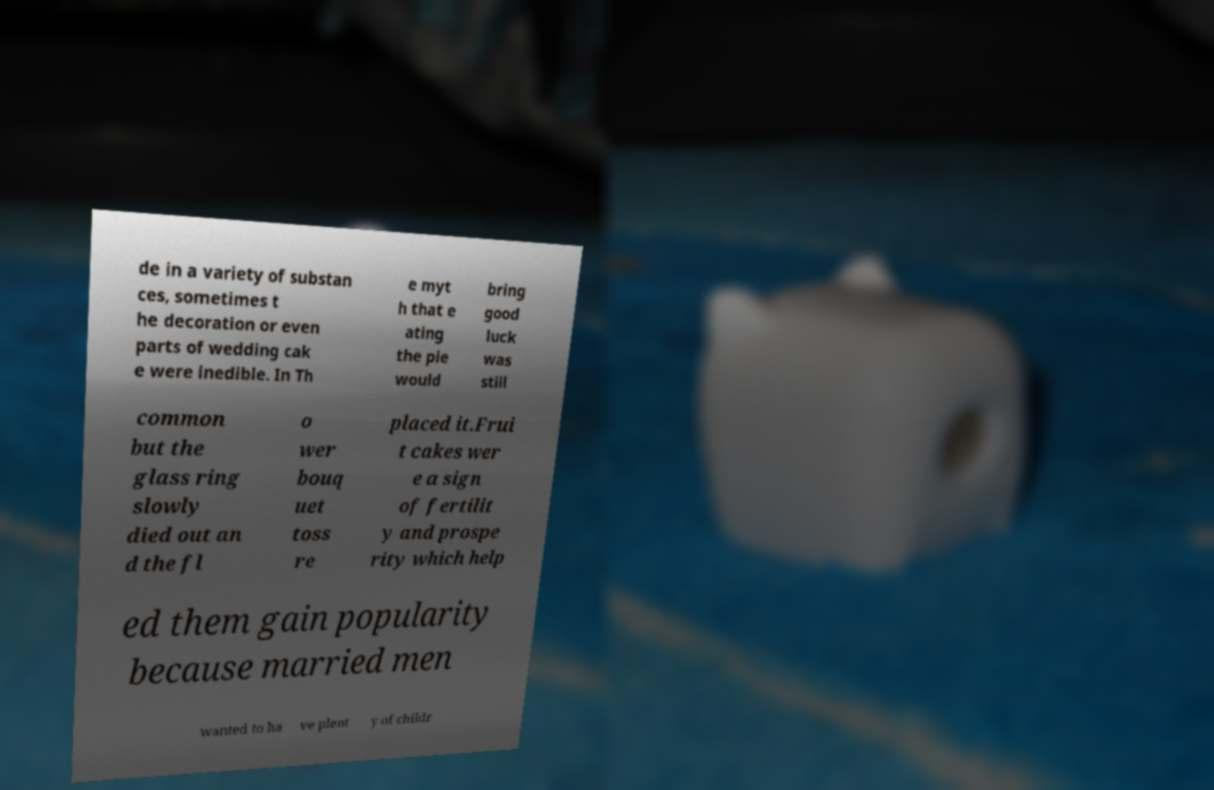Could you extract and type out the text from this image? de in a variety of substan ces, sometimes t he decoration or even parts of wedding cak e were inedible. In Th e myt h that e ating the pie would bring good luck was still common but the glass ring slowly died out an d the fl o wer bouq uet toss re placed it.Frui t cakes wer e a sign of fertilit y and prospe rity which help ed them gain popularity because married men wanted to ha ve plent y of childr 